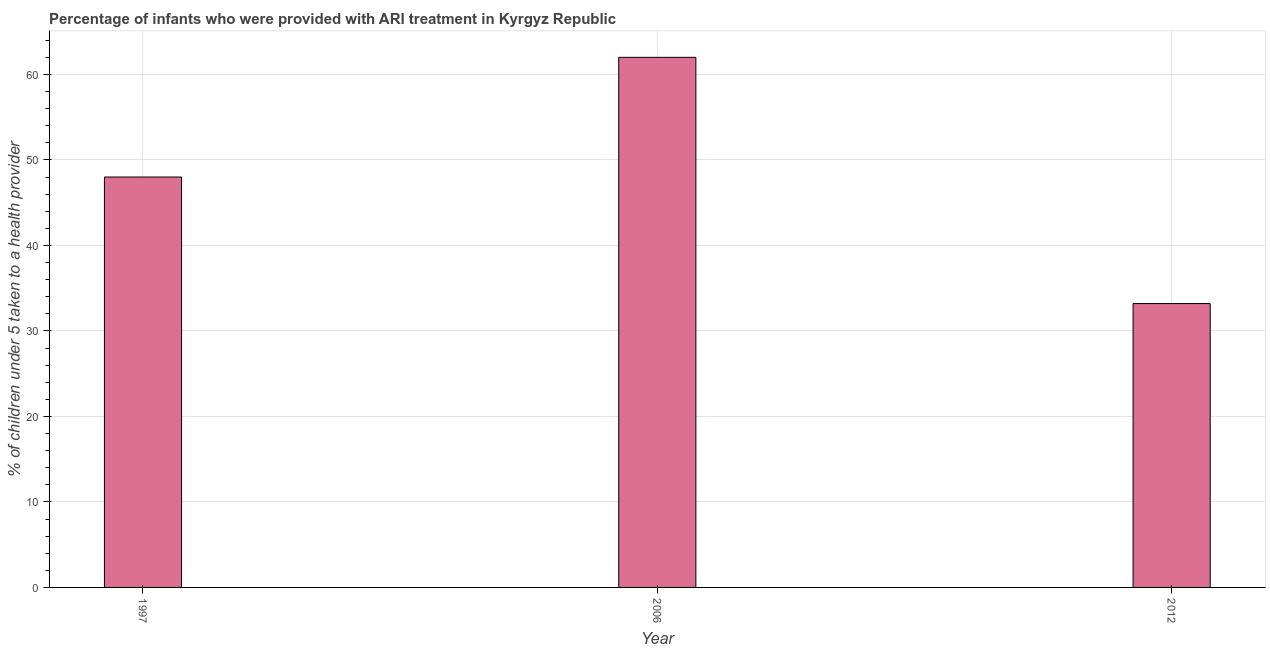What is the title of the graph?
Make the answer very short. Percentage of infants who were provided with ARI treatment in Kyrgyz Republic. What is the label or title of the X-axis?
Offer a very short reply. Year. What is the label or title of the Y-axis?
Offer a very short reply. % of children under 5 taken to a health provider. What is the percentage of children who were provided with ari treatment in 1997?
Your answer should be very brief. 48. Across all years, what is the minimum percentage of children who were provided with ari treatment?
Keep it short and to the point. 33.2. What is the sum of the percentage of children who were provided with ari treatment?
Your answer should be very brief. 143.2. What is the difference between the percentage of children who were provided with ari treatment in 2006 and 2012?
Your response must be concise. 28.8. What is the average percentage of children who were provided with ari treatment per year?
Offer a terse response. 47.73. What is the median percentage of children who were provided with ari treatment?
Offer a very short reply. 48. In how many years, is the percentage of children who were provided with ari treatment greater than 58 %?
Give a very brief answer. 1. What is the ratio of the percentage of children who were provided with ari treatment in 1997 to that in 2006?
Provide a succinct answer. 0.77. Is the percentage of children who were provided with ari treatment in 2006 less than that in 2012?
Your answer should be compact. No. What is the difference between the highest and the second highest percentage of children who were provided with ari treatment?
Your answer should be very brief. 14. What is the difference between the highest and the lowest percentage of children who were provided with ari treatment?
Your response must be concise. 28.8. In how many years, is the percentage of children who were provided with ari treatment greater than the average percentage of children who were provided with ari treatment taken over all years?
Offer a terse response. 2. How many years are there in the graph?
Give a very brief answer. 3. What is the % of children under 5 taken to a health provider of 1997?
Make the answer very short. 48. What is the % of children under 5 taken to a health provider of 2012?
Provide a short and direct response. 33.2. What is the difference between the % of children under 5 taken to a health provider in 1997 and 2006?
Give a very brief answer. -14. What is the difference between the % of children under 5 taken to a health provider in 2006 and 2012?
Offer a terse response. 28.8. What is the ratio of the % of children under 5 taken to a health provider in 1997 to that in 2006?
Offer a terse response. 0.77. What is the ratio of the % of children under 5 taken to a health provider in 1997 to that in 2012?
Your response must be concise. 1.45. What is the ratio of the % of children under 5 taken to a health provider in 2006 to that in 2012?
Your response must be concise. 1.87. 